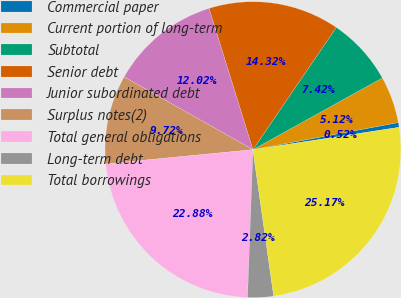<chart> <loc_0><loc_0><loc_500><loc_500><pie_chart><fcel>Commercial paper<fcel>Current portion of long-term<fcel>Subtotal<fcel>Senior debt<fcel>Junior subordinated debt<fcel>Surplus notes(2)<fcel>Total general obligations<fcel>Long-term debt<fcel>Total borrowings<nl><fcel>0.52%<fcel>5.12%<fcel>7.42%<fcel>14.32%<fcel>12.02%<fcel>9.72%<fcel>22.88%<fcel>2.82%<fcel>25.17%<nl></chart> 